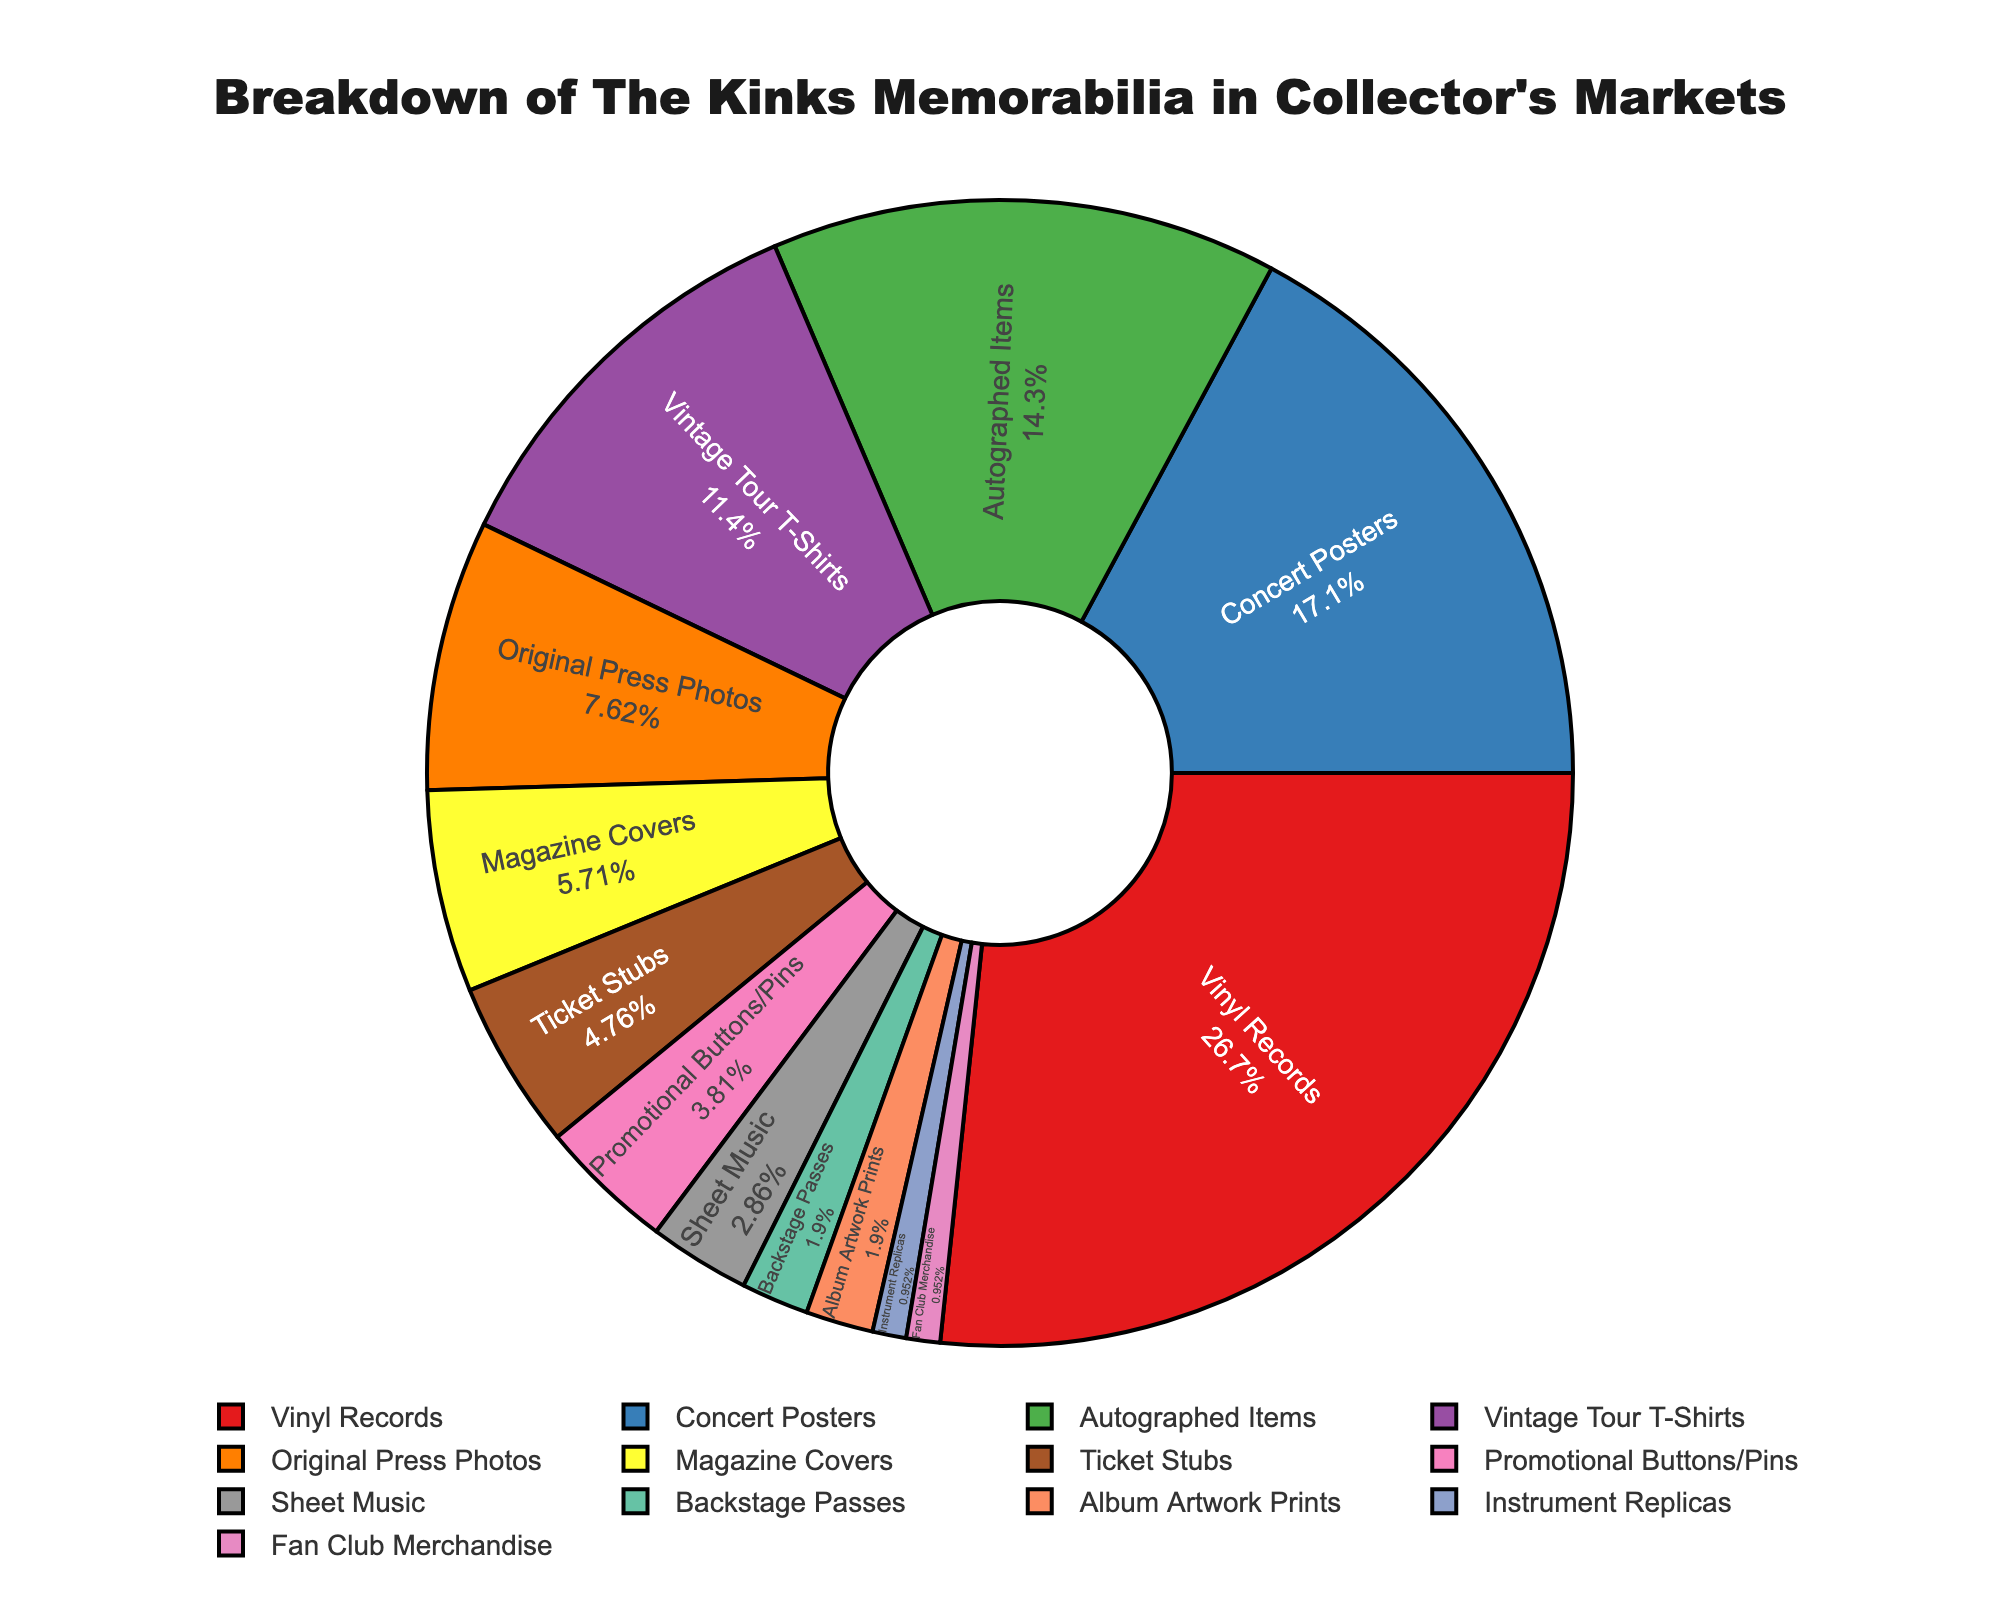what percentage of The Kinks memorabilia are Vinyl Records? Look at the portion of the pie chart labeled "Vinyl Records". The percentage indicated is 28%.
Answer: 28% Which memorabilia type is more common, Concert Posters or Vintage Tour T-Shirts? Compare the pie chart segments for "Concert Posters" and "Vintage Tour T-Shirts". "Concert Posters" has 18% while "Vintage Tour T-Shirts" has 12%. Therefore, Concert Posters are more common.
Answer: Concert Posters What is the combined percentage of Autographed Items and Original Press Photos? Find "Autographed Items" and "Original Press Photos" on the pie chart. Autographed Items have 15% and Original Press Photos have 8%. Adding them gives 15% + 8% = 23%.
Answer: 23% Which items have the smallest percentage, and what is it? Looking at the pie chart, both Instrument Replicas and Fan Club Merchandise have the smallest percentage, each with 1%.
Answer: 1% How much larger in percentage are Ticket Stubs compared to Backstage Passes? "Ticket Stubs" have 5% and "Backstage Passes" have 2%. Subtract 2% from 5% to find the difference: 5% - 2% = 3%.
Answer: 3% Is the percentage of Magazine Covers greater than the combined percentage of Sheet Music and Album Artwork Prints? "Magazine Covers" have 6%, while "Sheet Music" and "Album Artwork Prints" have 3% and 2%, respectively. Combined, Sheet Music and Album Artwork Prints are 3% + 2% = 5%, which is less than 6%.
Answer: Yes What is the difference between the percentages of the most common and least common memorabilia types? The most common type is "Vinyl Records" at 28%, and the least common types are "Instrument Replicas" and "Fan Club Merchandise" at 1% each. The difference is 28% - 1% = 27%.
Answer: 27% Which items are included in the total 10% sum of the smallest three categories, and what are their percentages? The three smallest categories in the pie chart are "Instrument Replicas", "Fan Club Merchandise", and "Backstage Passes". Their percentages are 1%, 1%, and 2% respectively. Summing them 1% + 1% + 2% = 4%. Similarly, adding "Album Artwork Prints" with 2%, "Sheet Music" with 3%, and "Promotional Buttons/Pins" with 4%, totaling to 10%. Therefore, Instrument Replicas, Fan Club Merchandise, and Backstage Passes sum to 4% and Album Artwork Prints, Sheet Music, and Promotional Buttons/Pins sum to 10%. The question incorrectly requests a smaller sum; the correct breakdown is: Promotional Buttons/Pins (4%), Sheet Music (3%), and Backstage Passes (2%).
Answer: 10% 